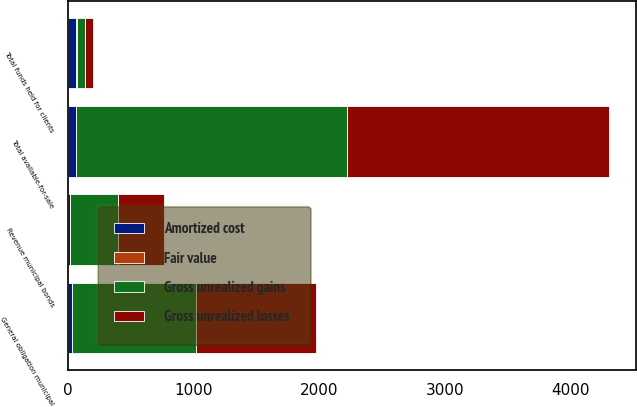Convert chart to OTSL. <chart><loc_0><loc_0><loc_500><loc_500><stacked_bar_chart><ecel><fcel>General obligation municipal<fcel>Revenue municipal bonds<fcel>Total available-for-sale<fcel>Total funds held for clients<nl><fcel>Gross unrealized losses<fcel>951.1<fcel>368<fcel>2085.2<fcel>67<nl><fcel>Amortized cost<fcel>33.7<fcel>13.8<fcel>67<fcel>67<nl><fcel>Fair value<fcel>0.3<fcel>0.1<fcel>0.4<fcel>0.6<nl><fcel>Gross unrealized gains<fcel>984.5<fcel>381.7<fcel>2151.8<fcel>67<nl></chart> 